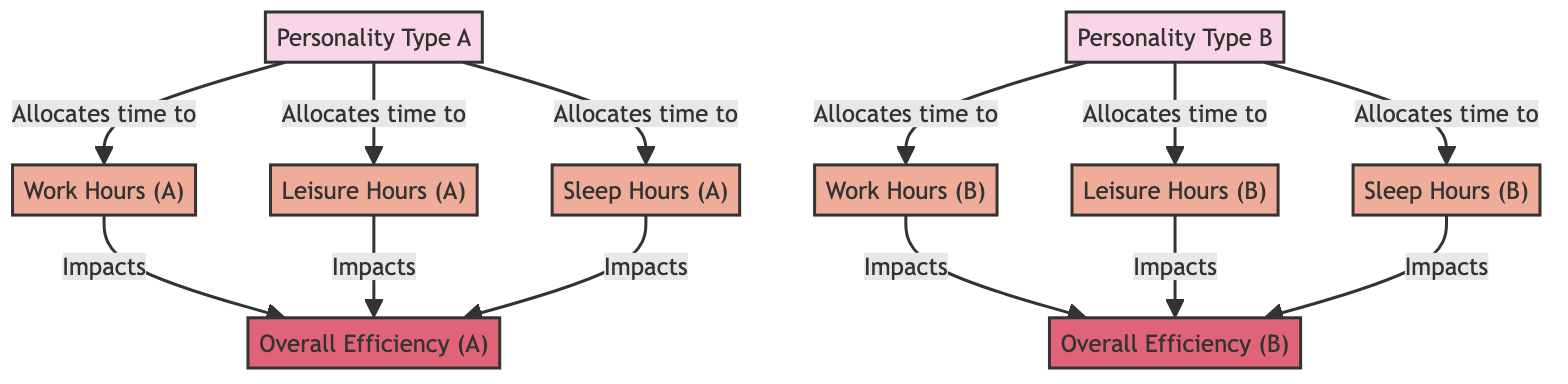What are the three types of time allocations for Personality Type A? The diagram lists three types of time allocations under Personality Type A: Work Hours, Leisure Hours, and Sleep Hours.
Answer: Work Hours, Leisure Hours, Sleep Hours Which personality type allocates time to Sleep Hours? The diagram shows that both Personality Type A and Personality Type B allocate time to Sleep Hours as indicated by the arrows leading to that node.
Answer: Personality Type A and Personality Type B How many total time allocation nodes are there in the diagram? The diagram presents a total of six time allocation nodes: Work Hours A, Leisure Hours A, Sleep Hours A for Personality A, and Work Hours B, Leisure Hours B, Sleep Hours B for Personality B, leading to a total of six.
Answer: Six What impact do Work Hours have on Overall Efficiency for both personality types? In the diagram, it is shown that Work Hours for both Personality Type A and Personality Type B have a direct impact on their respective Overall Efficiency nodes.
Answer: Impact on Overall Efficiency For Personality Type A, how many distinct factors influence Overall Efficiency? The diagram illustrates that there are three distinct factors for Personality Type A that influence Overall Efficiency, namely Work Hours, Leisure Hours, and Sleep Hours.
Answer: Three Which personality type has a direct connection to Overall Efficiency through Leisure Hours? The diagram depicts that both Personality Type A and Personality Type B have direct connections to Overall Efficiency through Leisure Hours.
Answer: Personality Type A and Personality Type B What is the relationship between Sleep Hours and Overall Efficiency for Personality Type B? The diagram indicates that Sleep Hours directly impact Overall Efficiency for Personality Type B, demonstrating their relationship where more sleep may influence productivity.
Answer: Direct impact How does the allocation of time to Leisure Hours affect Overall Efficiency for both personality types? The diagram shows that allocation of time to Leisure Hours plays a role in impacting Overall Efficiency for both Personality Type A and Personality Type B, suggesting that time spent in leisure is significant for productivity outcomes.
Answer: Impacts Overall Efficiency for both 